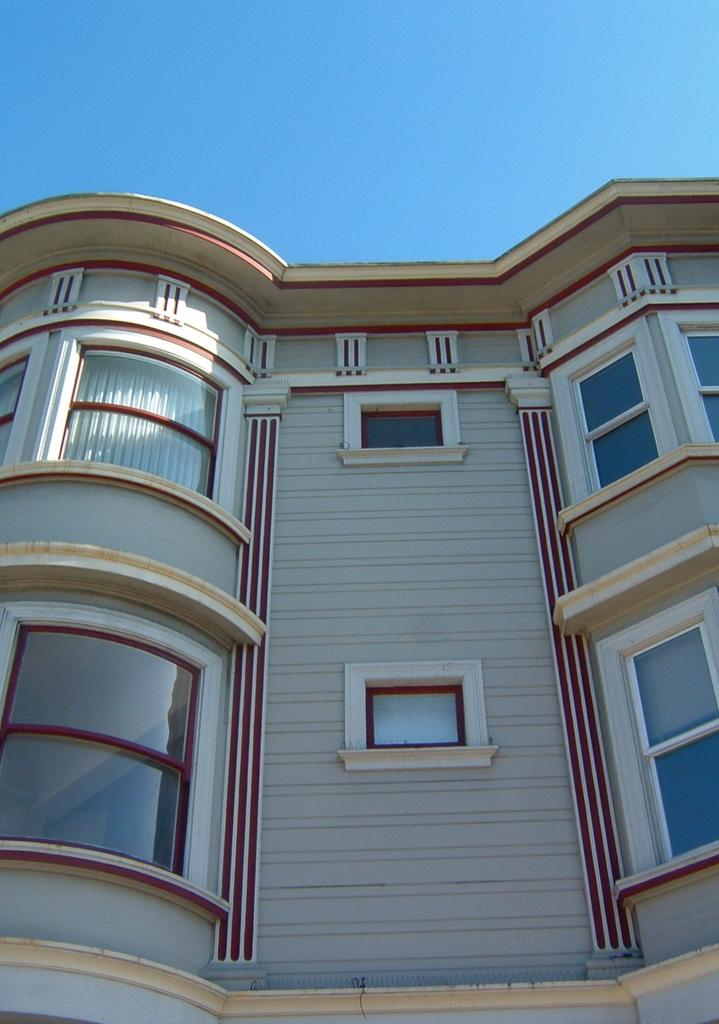What is the main subject in the image? There is a building in the image. What can be observed about the building's appearance? The building has red color designs. What is visible in the background of the image? The sky is visible in the background of the image. What is the weight of the iron trains visible in the image? There are no iron trains present in the image. 